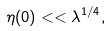<formula> <loc_0><loc_0><loc_500><loc_500>\eta ( 0 ) < < \lambda ^ { 1 / 4 } ,</formula> 